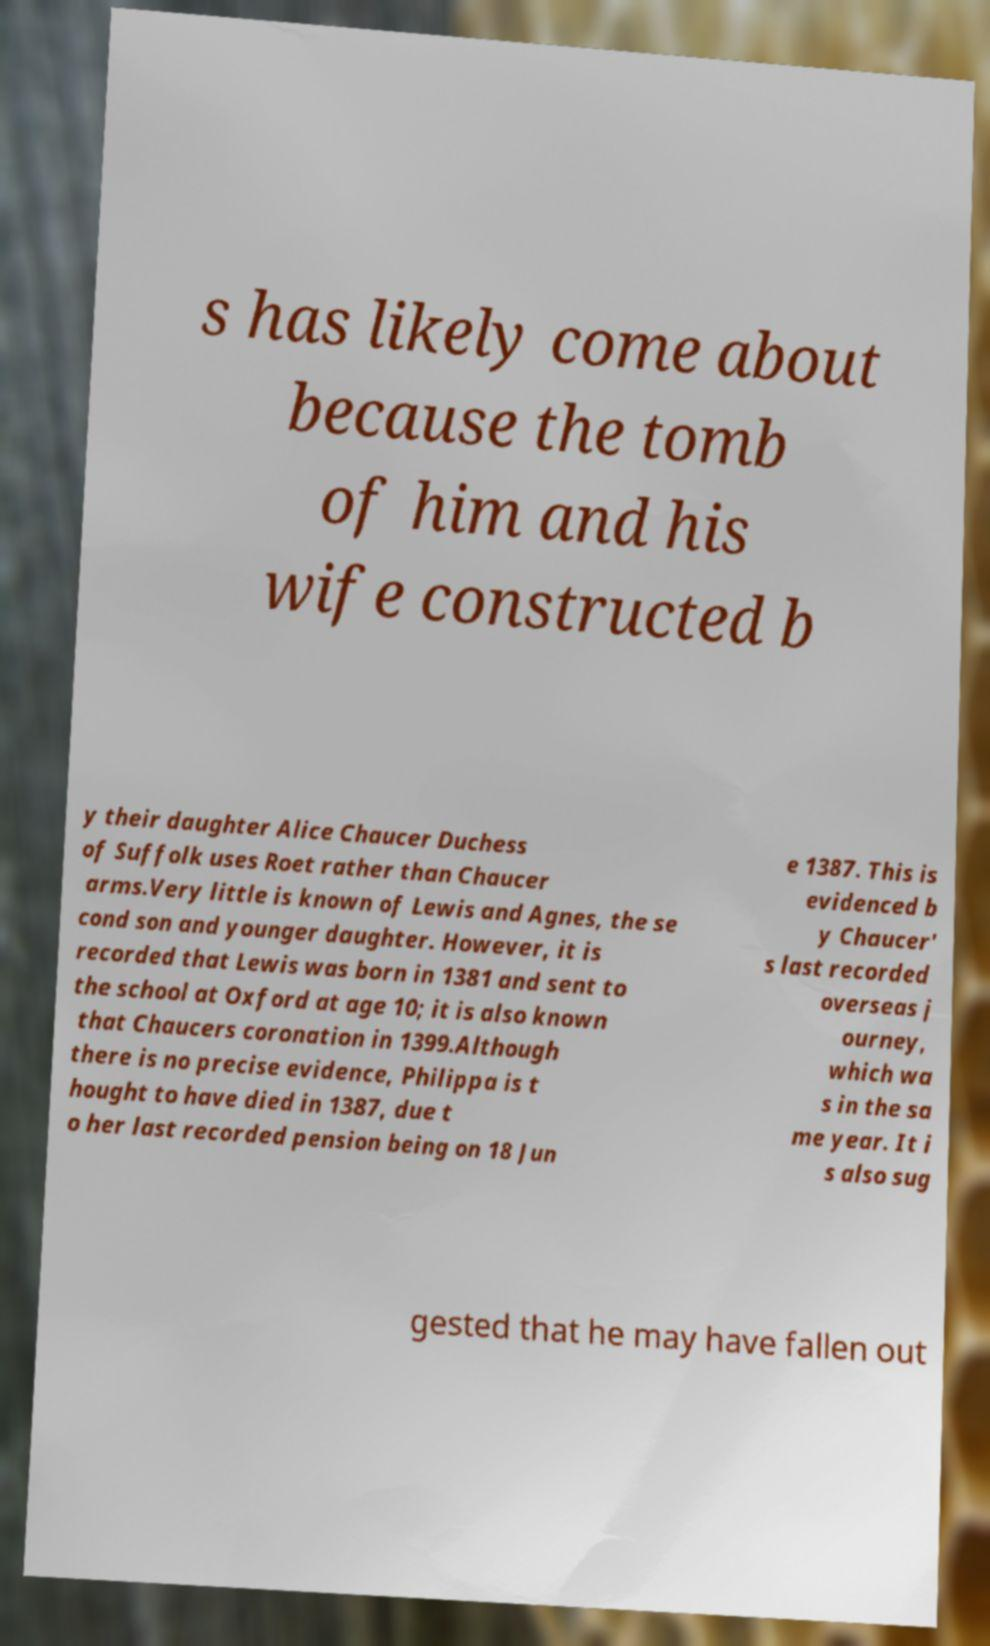Can you accurately transcribe the text from the provided image for me? s has likely come about because the tomb of him and his wife constructed b y their daughter Alice Chaucer Duchess of Suffolk uses Roet rather than Chaucer arms.Very little is known of Lewis and Agnes, the se cond son and younger daughter. However, it is recorded that Lewis was born in 1381 and sent to the school at Oxford at age 10; it is also known that Chaucers coronation in 1399.Although there is no precise evidence, Philippa is t hought to have died in 1387, due t o her last recorded pension being on 18 Jun e 1387. This is evidenced b y Chaucer' s last recorded overseas j ourney, which wa s in the sa me year. It i s also sug gested that he may have fallen out 